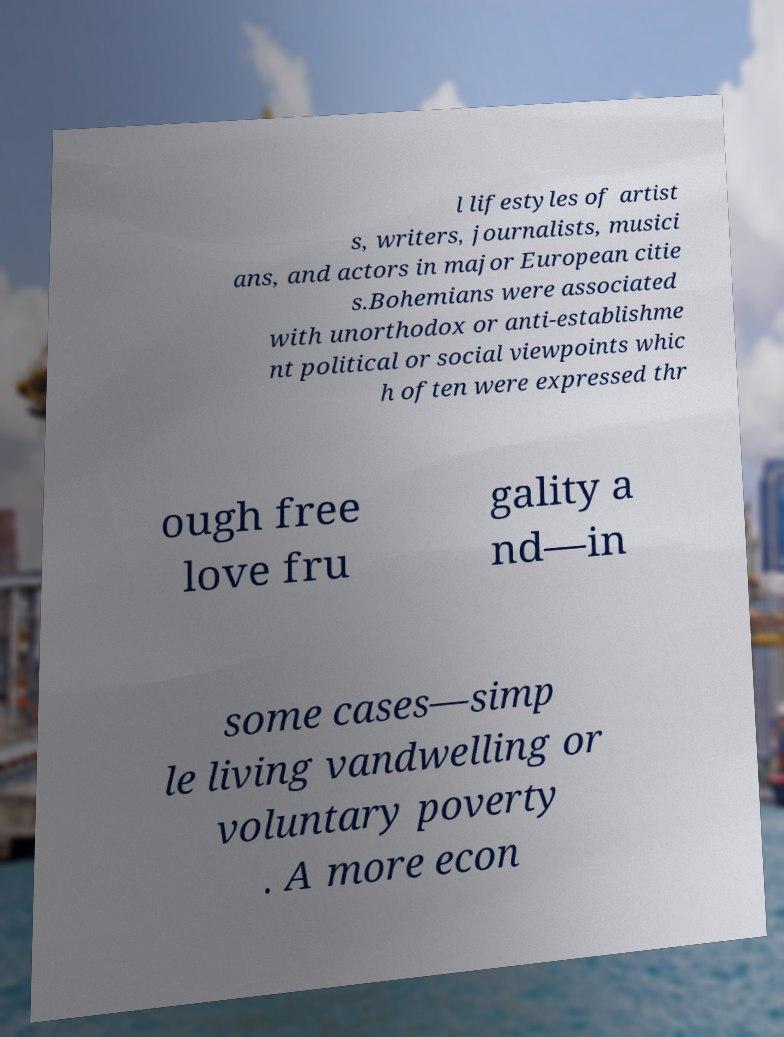Can you accurately transcribe the text from the provided image for me? l lifestyles of artist s, writers, journalists, musici ans, and actors in major European citie s.Bohemians were associated with unorthodox or anti-establishme nt political or social viewpoints whic h often were expressed thr ough free love fru gality a nd—in some cases—simp le living vandwelling or voluntary poverty . A more econ 